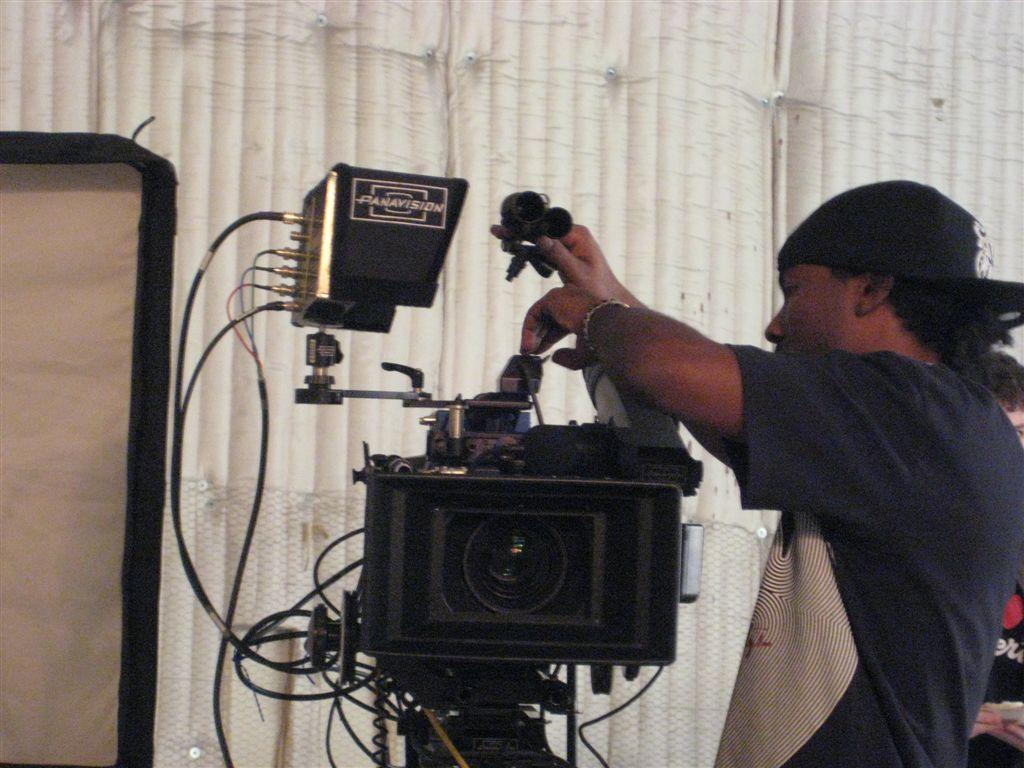What is the main subject of the image? There is a man in the image. Can you describe the man's attire? The man is wearing a cap. What is the man holding in the image? The man is holding a camera. What can be seen in the background of the image? There is a cloth and a mesh in the background, as well as a person. What type of cake is the scarecrow holding in the image? There is no scarecrow or cake present in the image. What is the pump's role in the image? There is no pump present in the image. 